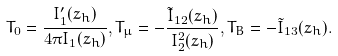Convert formula to latex. <formula><loc_0><loc_0><loc_500><loc_500>T _ { 0 } = \frac { I ^ { \prime } _ { 1 } ( z _ { h } ) } { 4 \pi I _ { 1 } ( z _ { h } ) } , T _ { \mu } = - \frac { \tilde { I } _ { 1 2 } ( z _ { h } ) } { I _ { 2 } ^ { 2 } ( z _ { h } ) } , T _ { B } = - \tilde { I } _ { 1 3 } ( z _ { h } ) .</formula> 